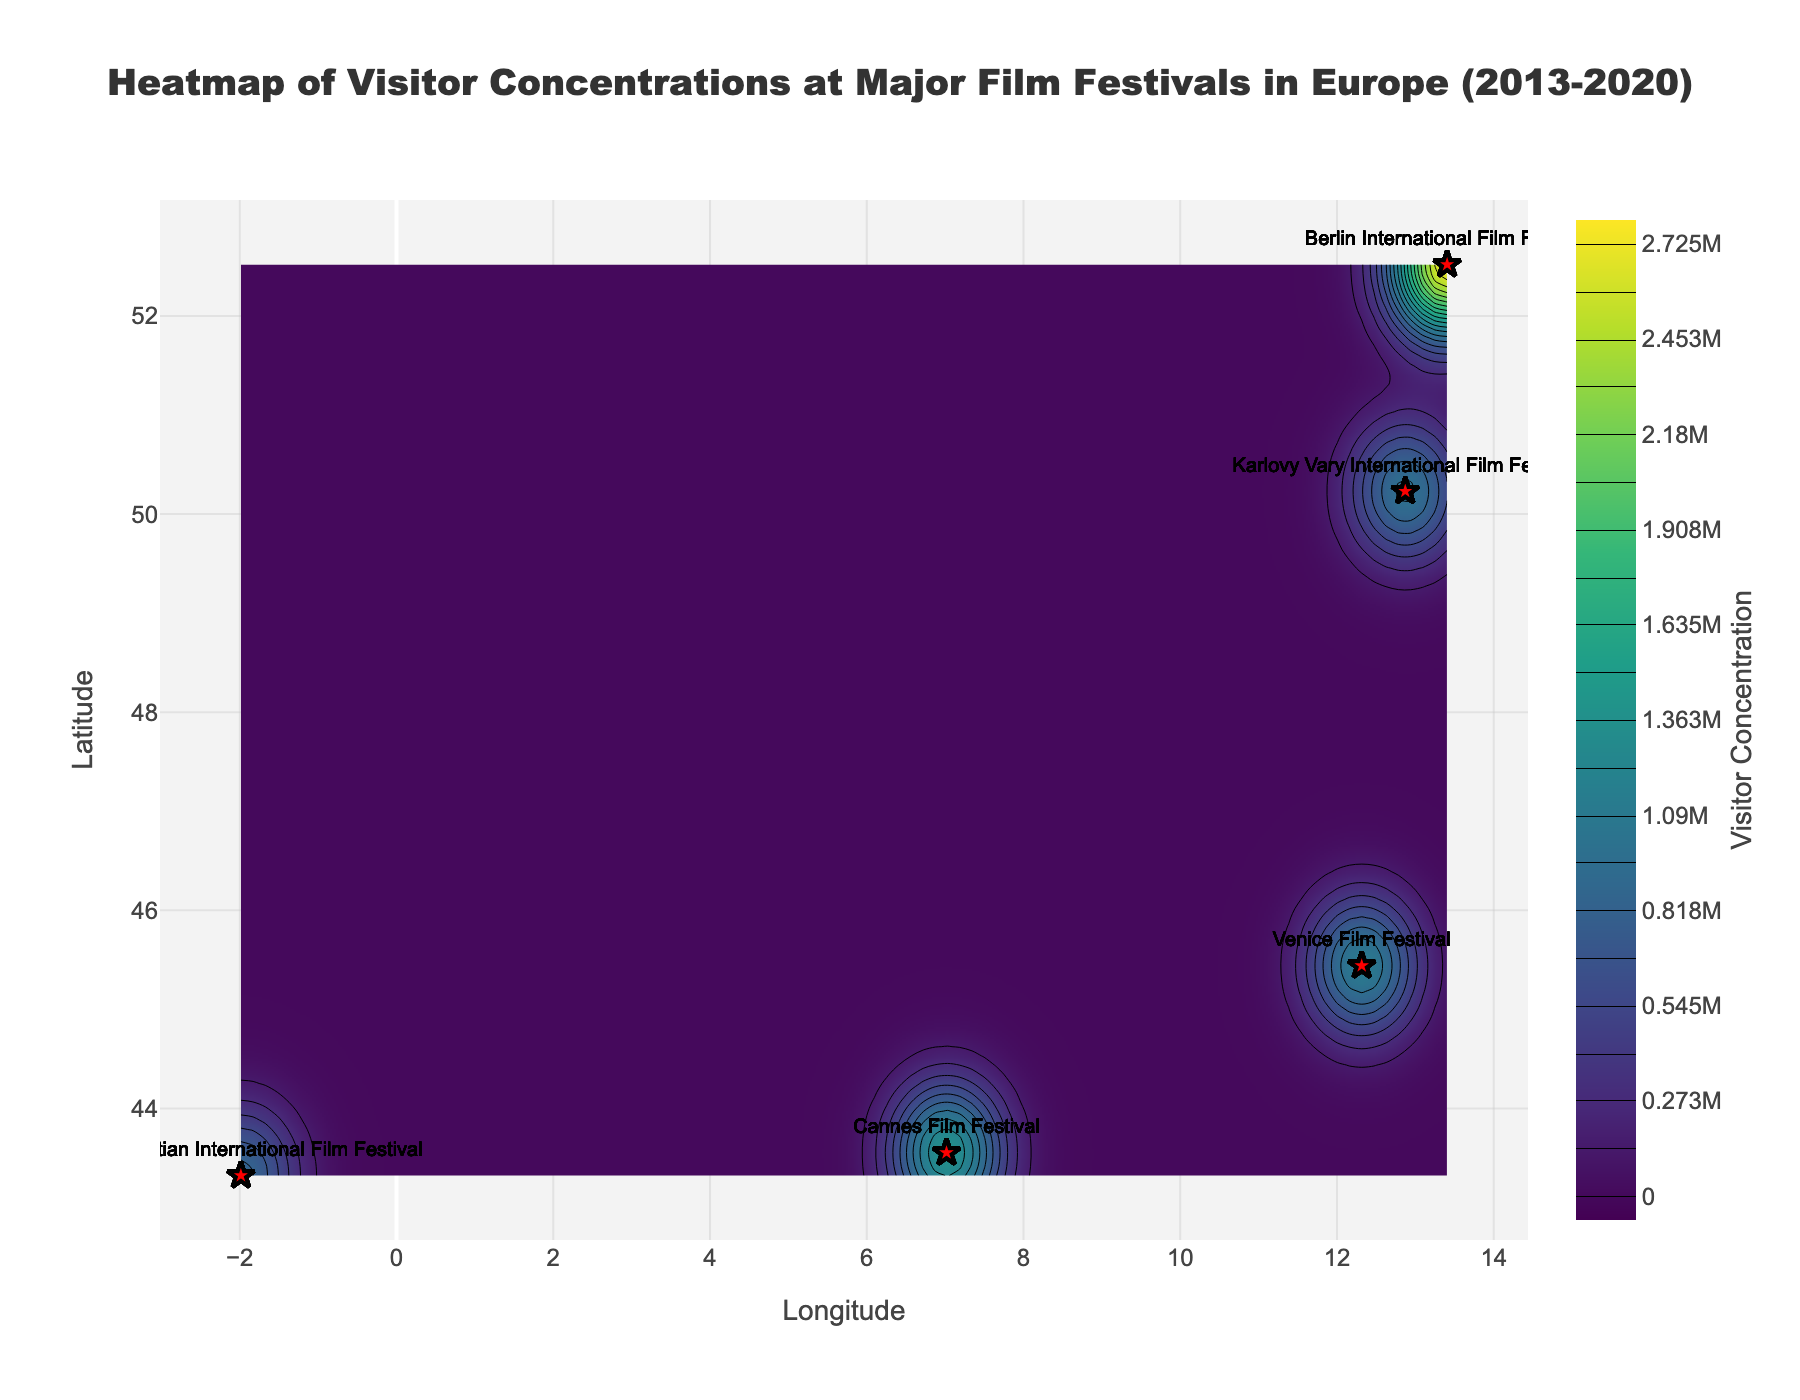How many major film festivals are represented in the plot? The plot legend or markers for different film festivals will indicate how many different festivals are included.
Answer: 5 Which festival had the highest visitor concentration? The Berlin International Film Festival had the highest visitor counts, which would make its contour areas show the most intense colors. Check the area with the darkest or most intense hue.
Answer: Berlin International Film Festival What is the approximate longitude range shown in the plot? The x-axis represents longitude, which spans from the minimum to the maximum longitude values found in the dataset.
Answer: -2 to 13 Which festival location shows the most densely packed visitor concentration after Berlin? After identifying Berlin's peak, compare other locations' color intensities. The second densest area should show the next most intense color range, likely indicated by festival markers.
Answer: Cannes Film Festival Which year had the highest visitor concentration at the Venice Film Festival? Locate the Venice marker and check the years linked with the steepest color gradient or densest hues around it.
Answer: 2020 What is the average visitor count at the Cannes Film Festival over the displayed years? Add the visitor counts for Cannes from 2013 to 2020 and divide by the number of years (8).
Answer: 172,500 Compare visitor concentration trends between Cannes and Karlovy Vary. Which one shows a steadier increase? Examine the gradient and concentration patterns around the respective markers for Cannes and Karlovy Vary, noting the year-by-year shift in hue density.
Answer: Cannes shows a steadier increase Which coordinates (latitude and longitude) host the largest number of unique festivals? Check the plotted points for overlaps in festival markers or locations sharing similar latitudes and longitudes.
Answer: 45.44, 12.32 (Venice) and 43.55, 7.02 (Cannes) What is the color gradient used in the contour plot? The color bar indicates what color scheme (Viridis) is applied to show different visitor concentrations.
Answer: Viridis How does San Sebastian’s visitor density compare to Venice's in 2013? Compare the color intensities (since it indicates visitor concentration) at the coordinates for San Sebastian and Venice in 2013. The higher density will have a stronger hue.
Answer: Venice is higher 